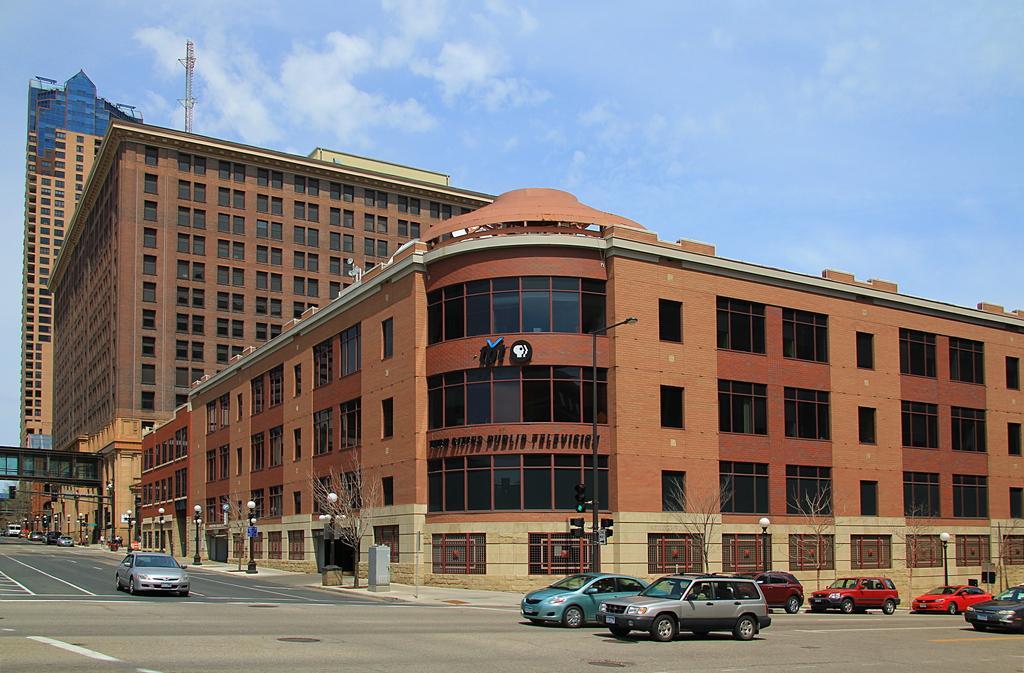Describe this image in one or two sentences. In this image, on the right side, we can see few cars which are moving on the road. On the left side, we can see a car which is moving on the road. In the background, we can see a street light, vehicle, footpath, building, glass window, towers, pole, bridge. At the top, we can see a sky, at the bottom, we can see a footpath and a road. 